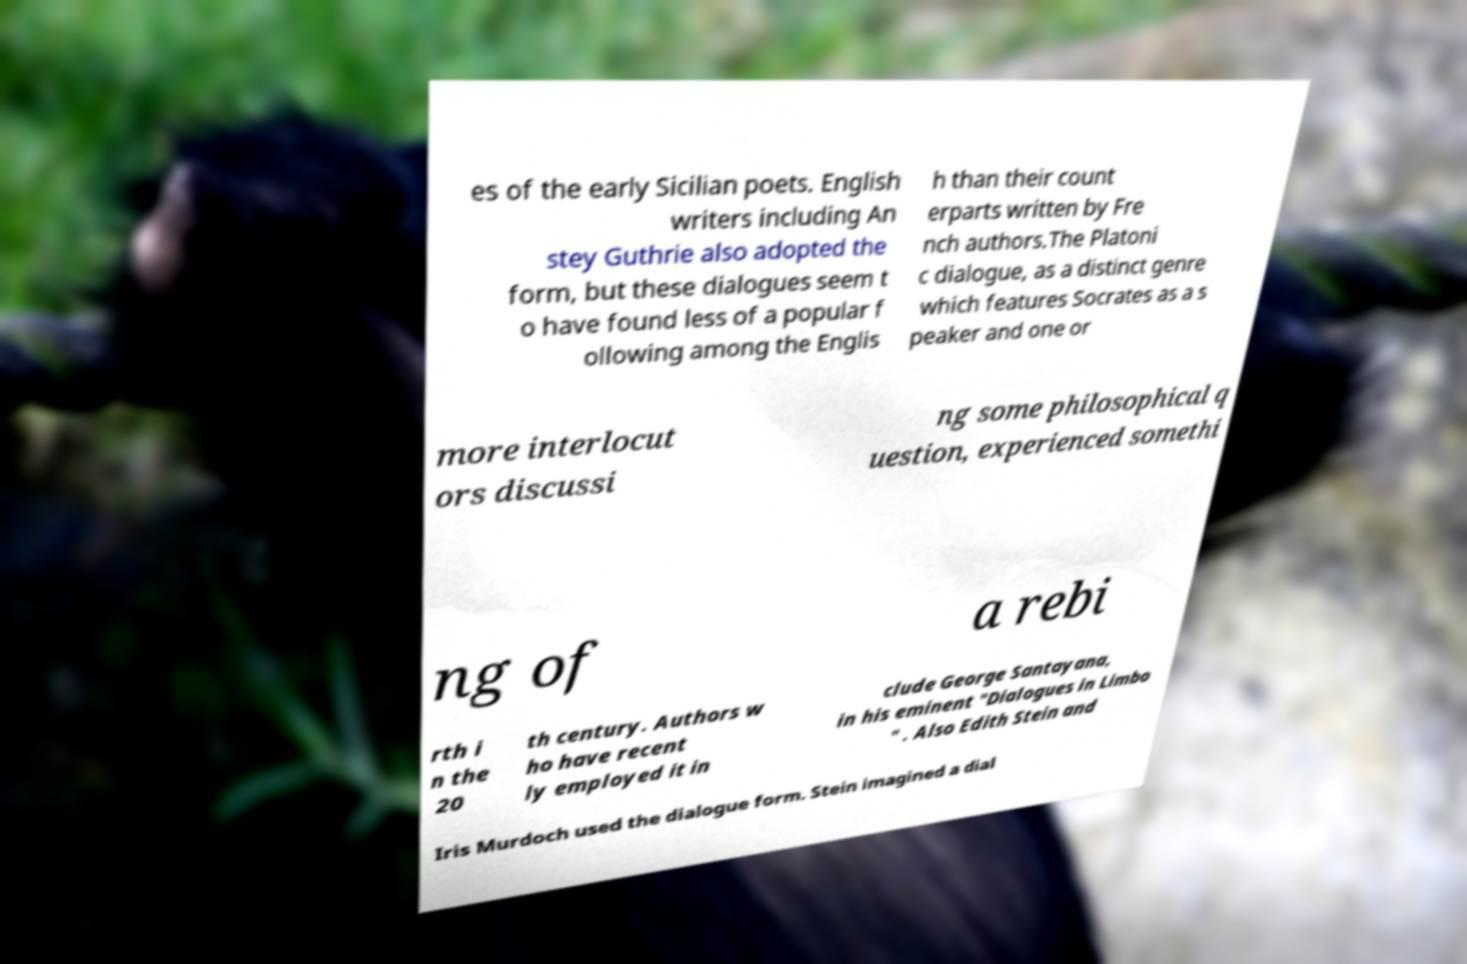Can you read and provide the text displayed in the image?This photo seems to have some interesting text. Can you extract and type it out for me? es of the early Sicilian poets. English writers including An stey Guthrie also adopted the form, but these dialogues seem t o have found less of a popular f ollowing among the Englis h than their count erparts written by Fre nch authors.The Platoni c dialogue, as a distinct genre which features Socrates as a s peaker and one or more interlocut ors discussi ng some philosophical q uestion, experienced somethi ng of a rebi rth i n the 20 th century. Authors w ho have recent ly employed it in clude George Santayana, in his eminent "Dialogues in Limbo " . Also Edith Stein and Iris Murdoch used the dialogue form. Stein imagined a dial 